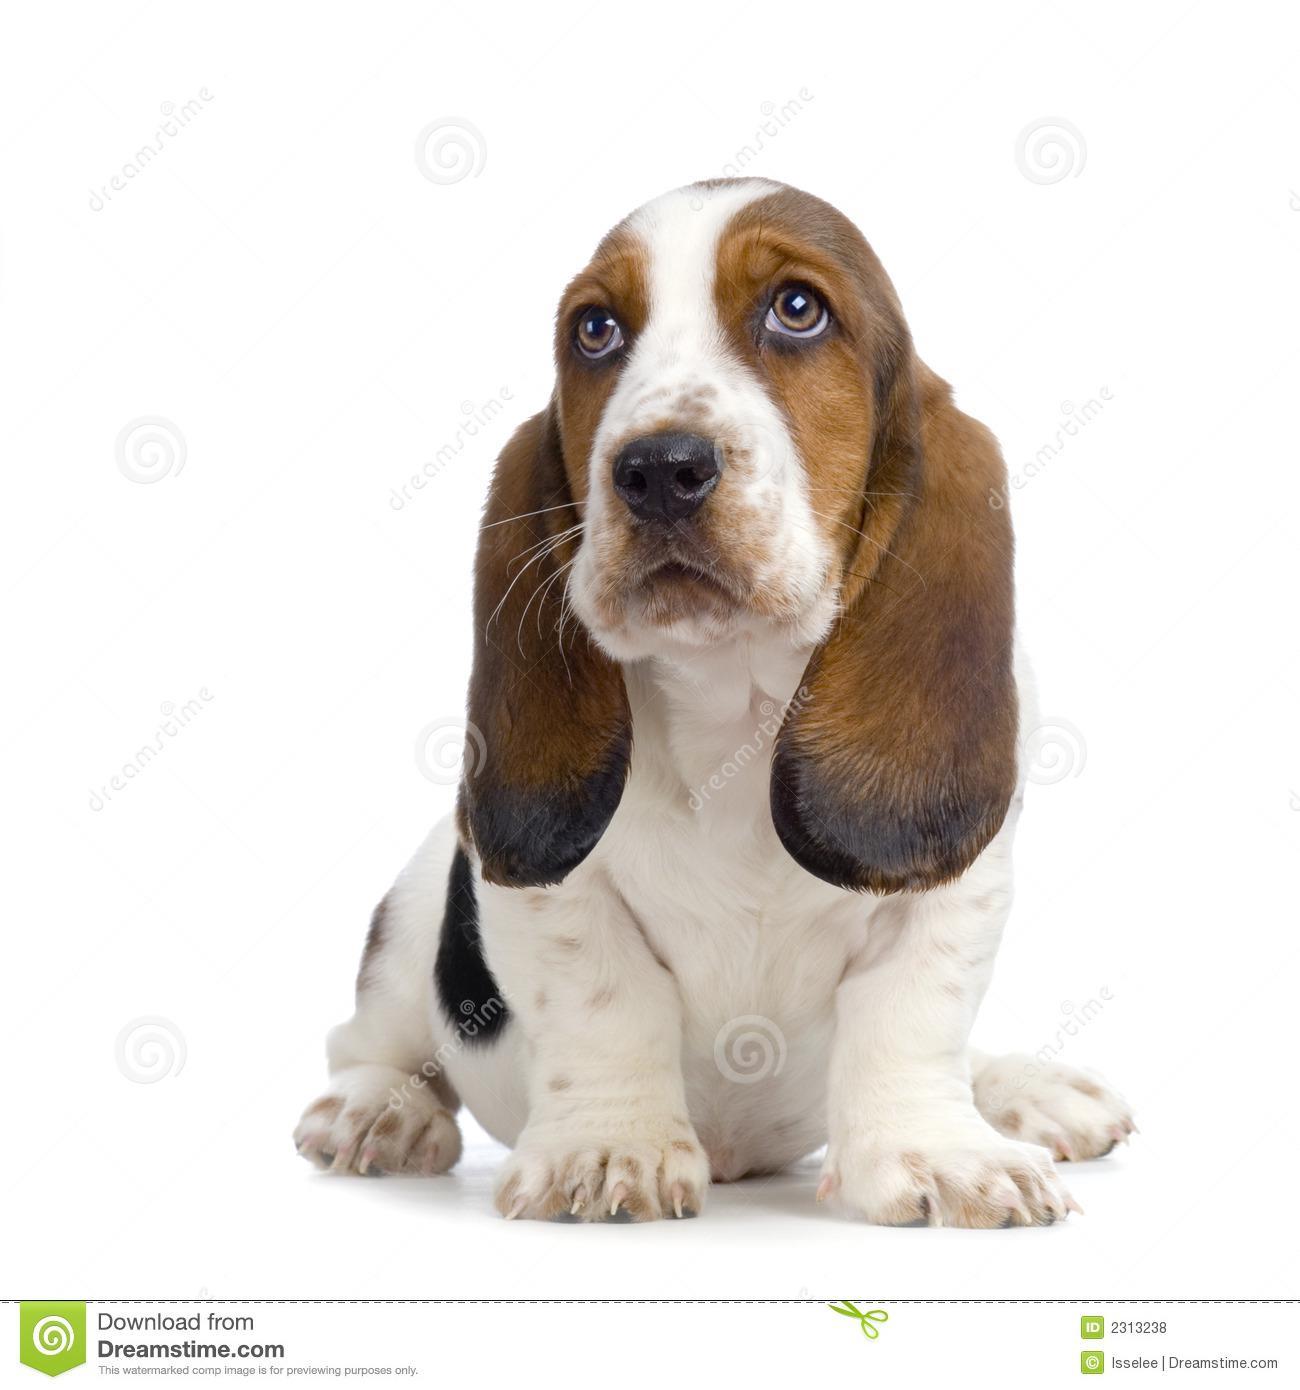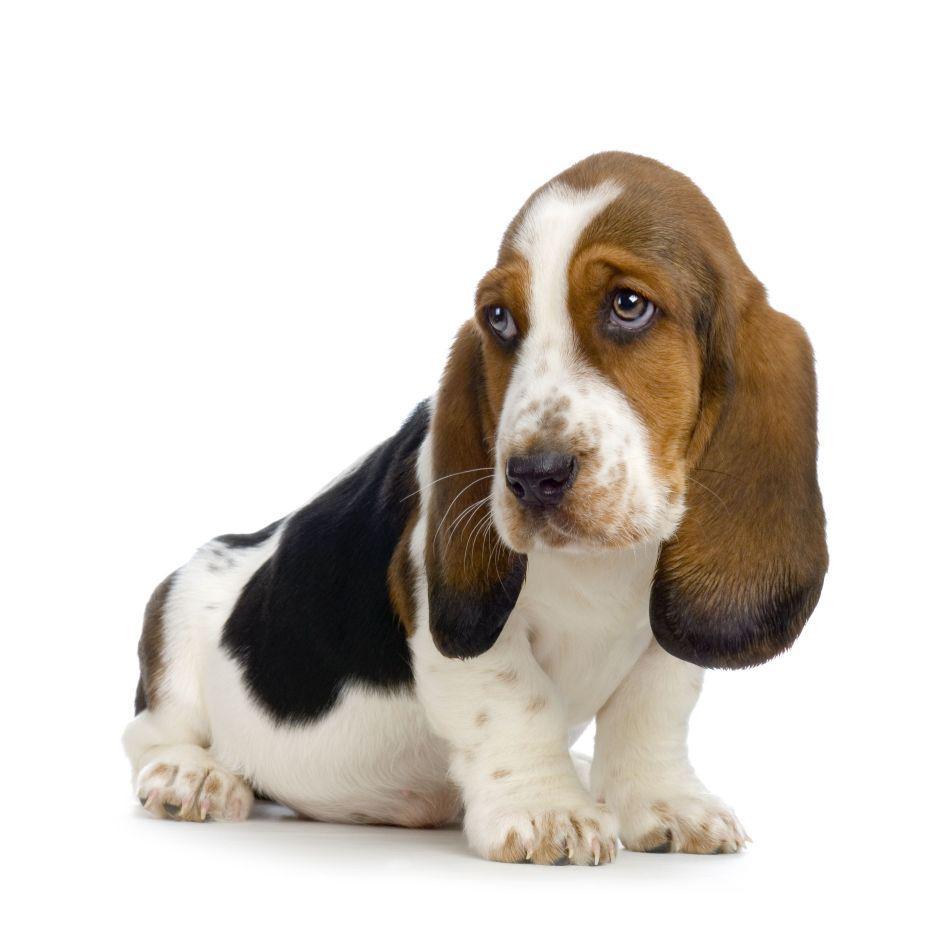The first image is the image on the left, the second image is the image on the right. For the images shown, is this caption "Both dogs are sitting." true? Answer yes or no. Yes. The first image is the image on the left, the second image is the image on the right. Examine the images to the left and right. Is the description "One of the dogs is sitting on a wooden surface." accurate? Answer yes or no. No. The first image is the image on the left, the second image is the image on the right. Given the left and right images, does the statement "The left image shows a basset pup on green grass." hold true? Answer yes or no. No. 